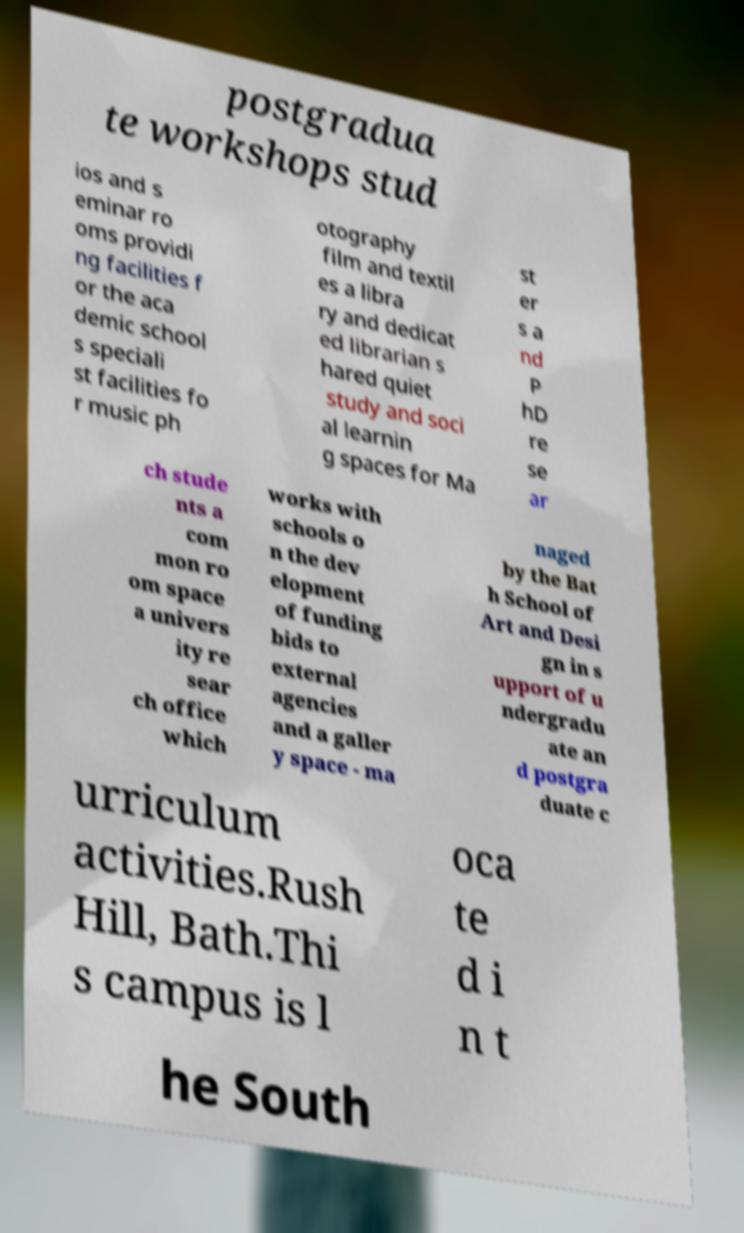Can you accurately transcribe the text from the provided image for me? postgradua te workshops stud ios and s eminar ro oms providi ng facilities f or the aca demic school s speciali st facilities fo r music ph otography film and textil es a libra ry and dedicat ed librarian s hared quiet study and soci al learnin g spaces for Ma st er s a nd P hD re se ar ch stude nts a com mon ro om space a univers ity re sear ch office which works with schools o n the dev elopment of funding bids to external agencies and a galler y space - ma naged by the Bat h School of Art and Desi gn in s upport of u ndergradu ate an d postgra duate c urriculum activities.Rush Hill, Bath.Thi s campus is l oca te d i n t he South 